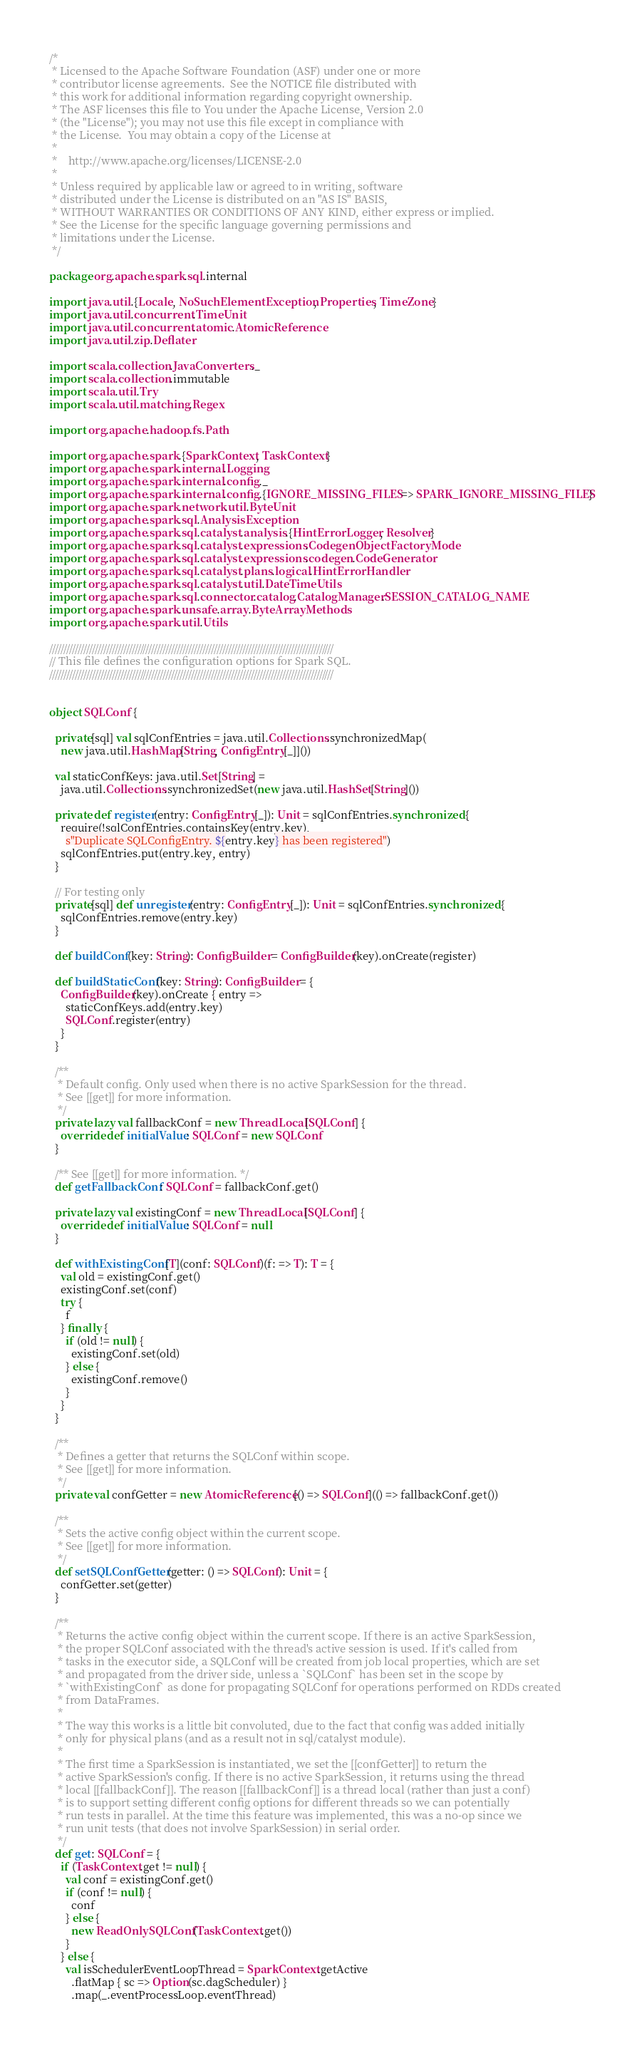<code> <loc_0><loc_0><loc_500><loc_500><_Scala_>/*
 * Licensed to the Apache Software Foundation (ASF) under one or more
 * contributor license agreements.  See the NOTICE file distributed with
 * this work for additional information regarding copyright ownership.
 * The ASF licenses this file to You under the Apache License, Version 2.0
 * (the "License"); you may not use this file except in compliance with
 * the License.  You may obtain a copy of the License at
 *
 *    http://www.apache.org/licenses/LICENSE-2.0
 *
 * Unless required by applicable law or agreed to in writing, software
 * distributed under the License is distributed on an "AS IS" BASIS,
 * WITHOUT WARRANTIES OR CONDITIONS OF ANY KIND, either express or implied.
 * See the License for the specific language governing permissions and
 * limitations under the License.
 */

package org.apache.spark.sql.internal

import java.util.{Locale, NoSuchElementException, Properties, TimeZone}
import java.util.concurrent.TimeUnit
import java.util.concurrent.atomic.AtomicReference
import java.util.zip.Deflater

import scala.collection.JavaConverters._
import scala.collection.immutable
import scala.util.Try
import scala.util.matching.Regex

import org.apache.hadoop.fs.Path

import org.apache.spark.{SparkContext, TaskContext}
import org.apache.spark.internal.Logging
import org.apache.spark.internal.config._
import org.apache.spark.internal.config.{IGNORE_MISSING_FILES => SPARK_IGNORE_MISSING_FILES}
import org.apache.spark.network.util.ByteUnit
import org.apache.spark.sql.AnalysisException
import org.apache.spark.sql.catalyst.analysis.{HintErrorLogger, Resolver}
import org.apache.spark.sql.catalyst.expressions.CodegenObjectFactoryMode
import org.apache.spark.sql.catalyst.expressions.codegen.CodeGenerator
import org.apache.spark.sql.catalyst.plans.logical.HintErrorHandler
import org.apache.spark.sql.catalyst.util.DateTimeUtils
import org.apache.spark.sql.connector.catalog.CatalogManager.SESSION_CATALOG_NAME
import org.apache.spark.unsafe.array.ByteArrayMethods
import org.apache.spark.util.Utils

////////////////////////////////////////////////////////////////////////////////////////////////////
// This file defines the configuration options for Spark SQL.
////////////////////////////////////////////////////////////////////////////////////////////////////


object SQLConf {

  private[sql] val sqlConfEntries = java.util.Collections.synchronizedMap(
    new java.util.HashMap[String, ConfigEntry[_]]())

  val staticConfKeys: java.util.Set[String] =
    java.util.Collections.synchronizedSet(new java.util.HashSet[String]())

  private def register(entry: ConfigEntry[_]): Unit = sqlConfEntries.synchronized {
    require(!sqlConfEntries.containsKey(entry.key),
      s"Duplicate SQLConfigEntry. ${entry.key} has been registered")
    sqlConfEntries.put(entry.key, entry)
  }

  // For testing only
  private[sql] def unregister(entry: ConfigEntry[_]): Unit = sqlConfEntries.synchronized {
    sqlConfEntries.remove(entry.key)
  }

  def buildConf(key: String): ConfigBuilder = ConfigBuilder(key).onCreate(register)

  def buildStaticConf(key: String): ConfigBuilder = {
    ConfigBuilder(key).onCreate { entry =>
      staticConfKeys.add(entry.key)
      SQLConf.register(entry)
    }
  }

  /**
   * Default config. Only used when there is no active SparkSession for the thread.
   * See [[get]] for more information.
   */
  private lazy val fallbackConf = new ThreadLocal[SQLConf] {
    override def initialValue: SQLConf = new SQLConf
  }

  /** See [[get]] for more information. */
  def getFallbackConf: SQLConf = fallbackConf.get()

  private lazy val existingConf = new ThreadLocal[SQLConf] {
    override def initialValue: SQLConf = null
  }

  def withExistingConf[T](conf: SQLConf)(f: => T): T = {
    val old = existingConf.get()
    existingConf.set(conf)
    try {
      f
    } finally {
      if (old != null) {
        existingConf.set(old)
      } else {
        existingConf.remove()
      }
    }
  }

  /**
   * Defines a getter that returns the SQLConf within scope.
   * See [[get]] for more information.
   */
  private val confGetter = new AtomicReference[() => SQLConf](() => fallbackConf.get())

  /**
   * Sets the active config object within the current scope.
   * See [[get]] for more information.
   */
  def setSQLConfGetter(getter: () => SQLConf): Unit = {
    confGetter.set(getter)
  }

  /**
   * Returns the active config object within the current scope. If there is an active SparkSession,
   * the proper SQLConf associated with the thread's active session is used. If it's called from
   * tasks in the executor side, a SQLConf will be created from job local properties, which are set
   * and propagated from the driver side, unless a `SQLConf` has been set in the scope by
   * `withExistingConf` as done for propagating SQLConf for operations performed on RDDs created
   * from DataFrames.
   *
   * The way this works is a little bit convoluted, due to the fact that config was added initially
   * only for physical plans (and as a result not in sql/catalyst module).
   *
   * The first time a SparkSession is instantiated, we set the [[confGetter]] to return the
   * active SparkSession's config. If there is no active SparkSession, it returns using the thread
   * local [[fallbackConf]]. The reason [[fallbackConf]] is a thread local (rather than just a conf)
   * is to support setting different config options for different threads so we can potentially
   * run tests in parallel. At the time this feature was implemented, this was a no-op since we
   * run unit tests (that does not involve SparkSession) in serial order.
   */
  def get: SQLConf = {
    if (TaskContext.get != null) {
      val conf = existingConf.get()
      if (conf != null) {
        conf
      } else {
        new ReadOnlySQLConf(TaskContext.get())
      }
    } else {
      val isSchedulerEventLoopThread = SparkContext.getActive
        .flatMap { sc => Option(sc.dagScheduler) }
        .map(_.eventProcessLoop.eventThread)</code> 